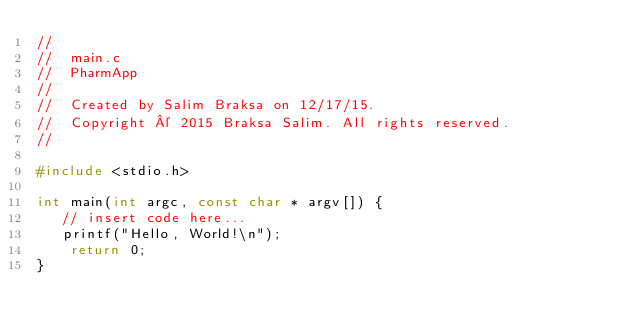Convert code to text. <code><loc_0><loc_0><loc_500><loc_500><_C_>//
//  main.c
//  PharmApp
//
//  Created by Salim Braksa on 12/17/15.
//  Copyright © 2015 Braksa Salim. All rights reserved.
//

#include <stdio.h>

int main(int argc, const char * argv[]) {
   // insert code here...
   printf("Hello, World!\n");
    return 0;
}
</code> 